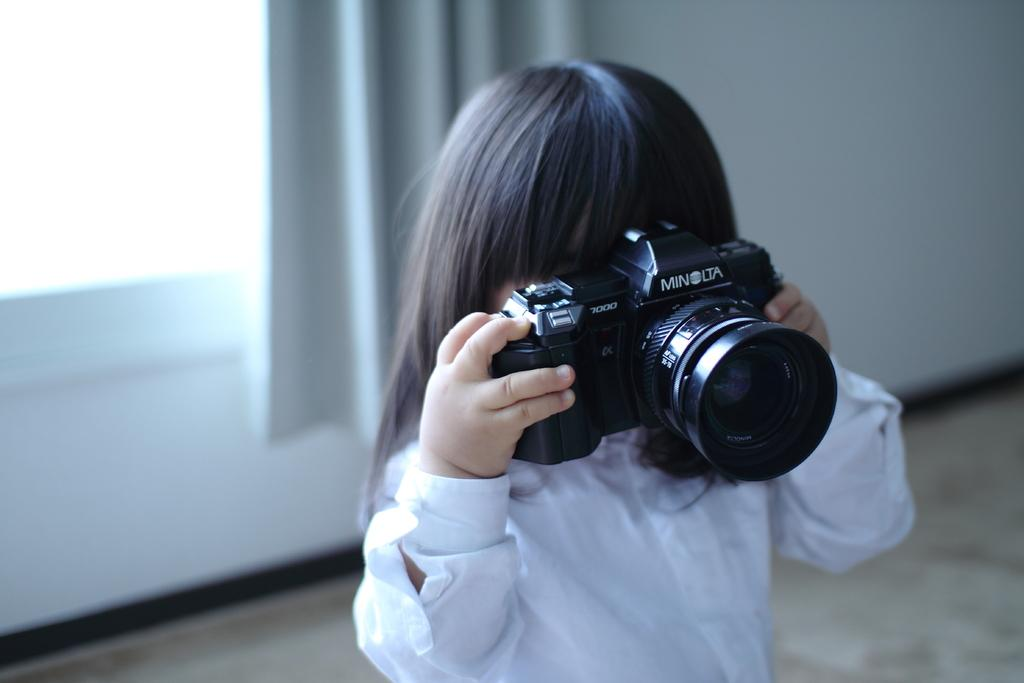Who is the main subject in the image? There is a girl in the center of the image. What is the girl wearing? The girl is wearing a white dress. What is the girl holding in her hand? The girl is holding a camera in her hand. What can be seen in the background of the image? There is a wall, a window, and a curtain associated with the window in the background of the image. What type of leaf can be seen falling from the tree in the image? There is no tree or leaf present in the image. How many oranges are visible on the bed in the image? There is no bed or oranges present in the image. 